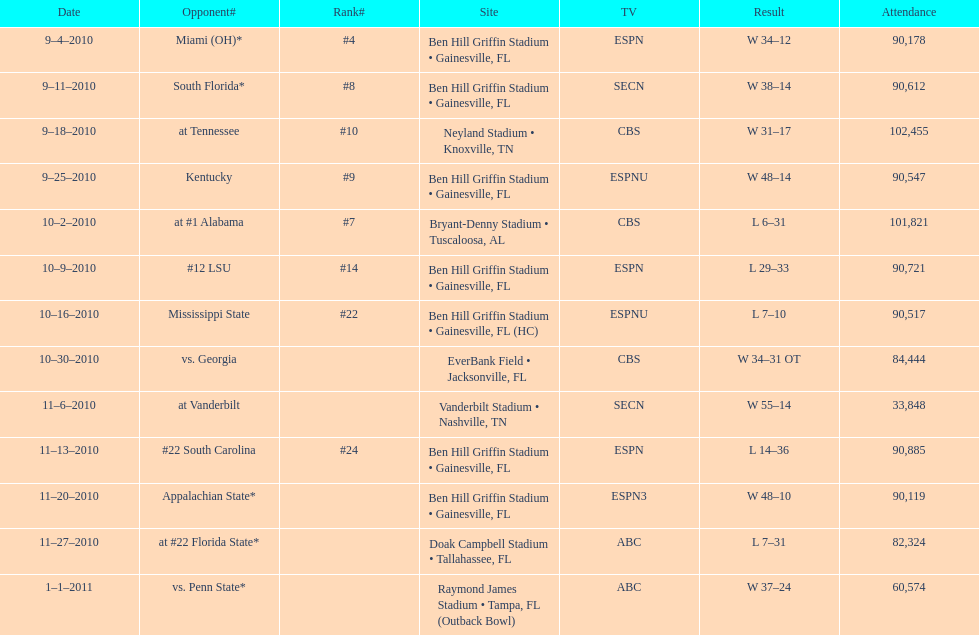What tv network showed the largest number of games during the 2010/2011 season? ESPN. 